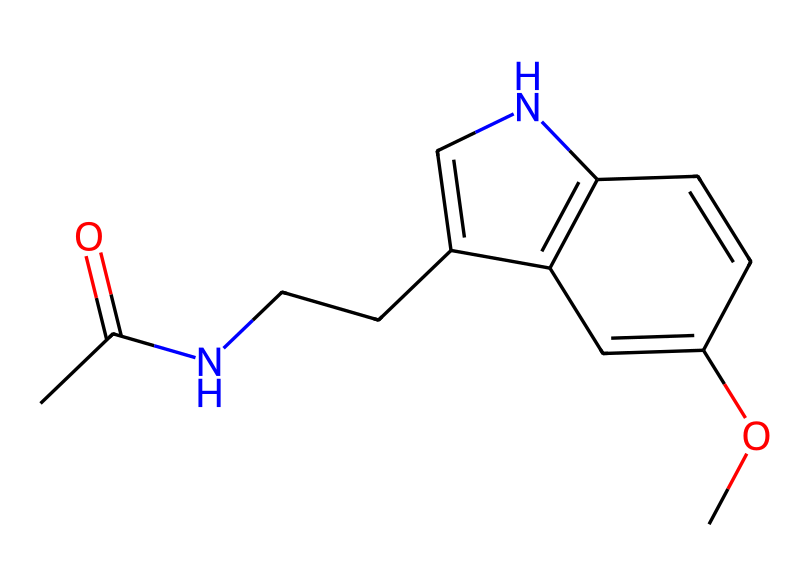What is the molecular formula of melatonin? To determine the molecular formula, we analyze the SMILES representation and count the number of carbon (C), hydrogen (H), nitrogen (N), and oxygen (O) atoms. The molecular formula derived from the structure is C13H16N2O2.
Answer: C13H16N2O2 How many rings are present in the structure of melatonin? By inspecting the SMILES representation, we identify the cyclic structures. The structure contains one fused ring system (the indole portion), indicating that there is one ring in total.
Answer: 1 What functional group is present in melatonin that is indicative of its properties? In the SMILES representation, there is an acetyl group (CC(=O)). This functional group is commonly associated with acetylated compounds and can influence the solubility and reactivity of the molecule.
Answer: acetyl group How many double bonds are in the melatonin structure? From the SMILES, we note the presence of double bonds including one in the carbonyl (C=O) of the acetyl group and one in the ring structure (C=C). This totals to two double bonds in the molecule.
Answer: 2 What type of chemical is melatonin classified as? Analyzing the structure and its functional groups, melatonin fits the classification of an indoleamine, which is a subclass of biochemicals known for their role in neurotransmission and hormonal activity.
Answer: indoleamine What characteristic of melatonin's structure suggests it plays a role in the body’s sleep cycle? The presence of a nitrogen atom in the indole derived framework suggests a potential role in neurotransmission. Additionally, the overall structure is conducive to binding with specific receptors in the brain, suggesting its regulatory function in circadian rhythms.
Answer: nitrogen atom 